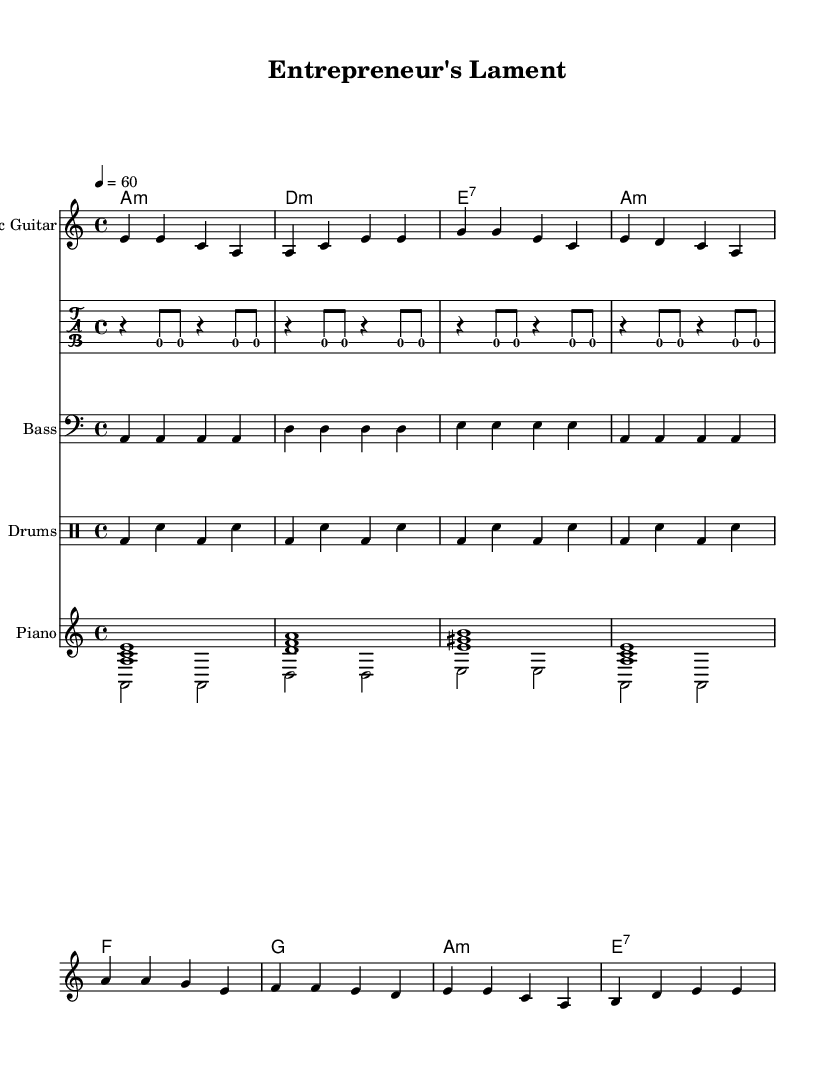What is the key signature of this music? The key signature indicates A minor, which includes no sharps or flats. This is determined by the notation present at the beginning of the score following the word "key."
Answer: A minor What is the time signature of this piece? The time signature shows a 4/4 pattern, meaning there are four beats in each measure, indicated visually at the beginning of the score.
Answer: 4/4 What is the tempo marking for the piece? The tempo is set to 60 beats per minute, indicated by "4 = 60," meaning quarter notes will pulse at this speed.
Answer: 60 What are the primary chords used in this music? The primary chords in this piece include A minor, D minor, E7, and F major. These can be identified in the chord progression section with each chord marked in a simplified manner.
Answer: A minor, D minor, E7, F major How many measures are there in the verse? Counting the measures in the melody for the verse shows there are 4 measures before repeating, which can be visually counted at the beginning and also through the rhythmic structure displayed.
Answer: 4 What unique features of Electric Blues can you find in this piece? The piece contains a soulful quality typical of Electric Blues, emphasized by its use of extended chords like E7 and a pattern that conveys emotional storytelling through melody, a characteristic distinguishing it from other genres.
Answer: Soulful quality, E7 chord 